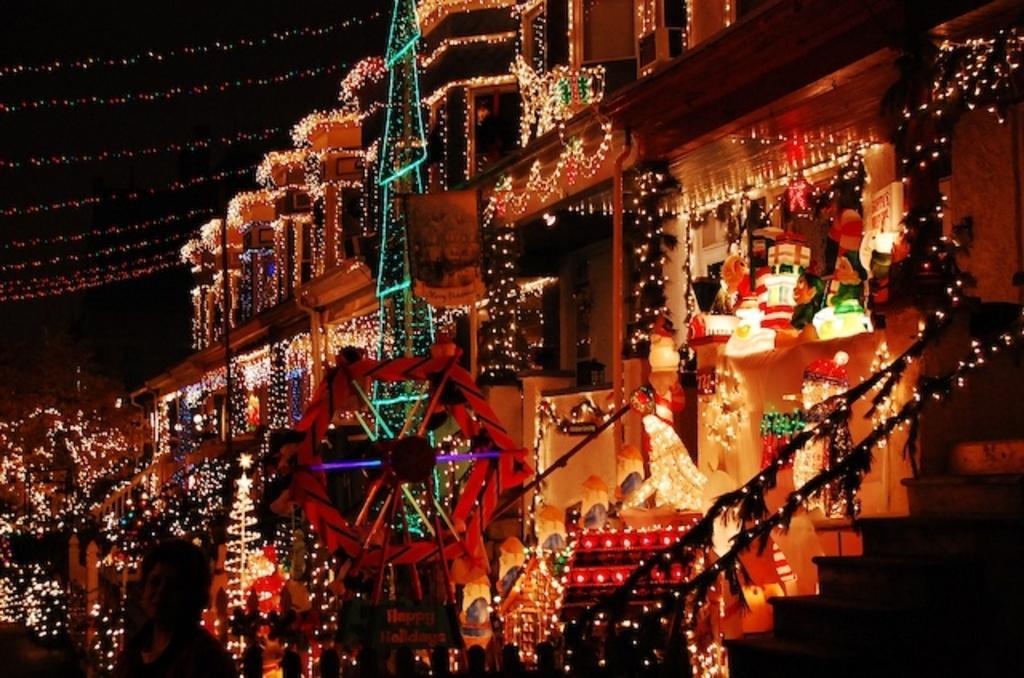Please provide a concise description of this image. In this image we can see a building, here are the lights, here is the x-mass tree, here is the staircase, at above here is the sky. 